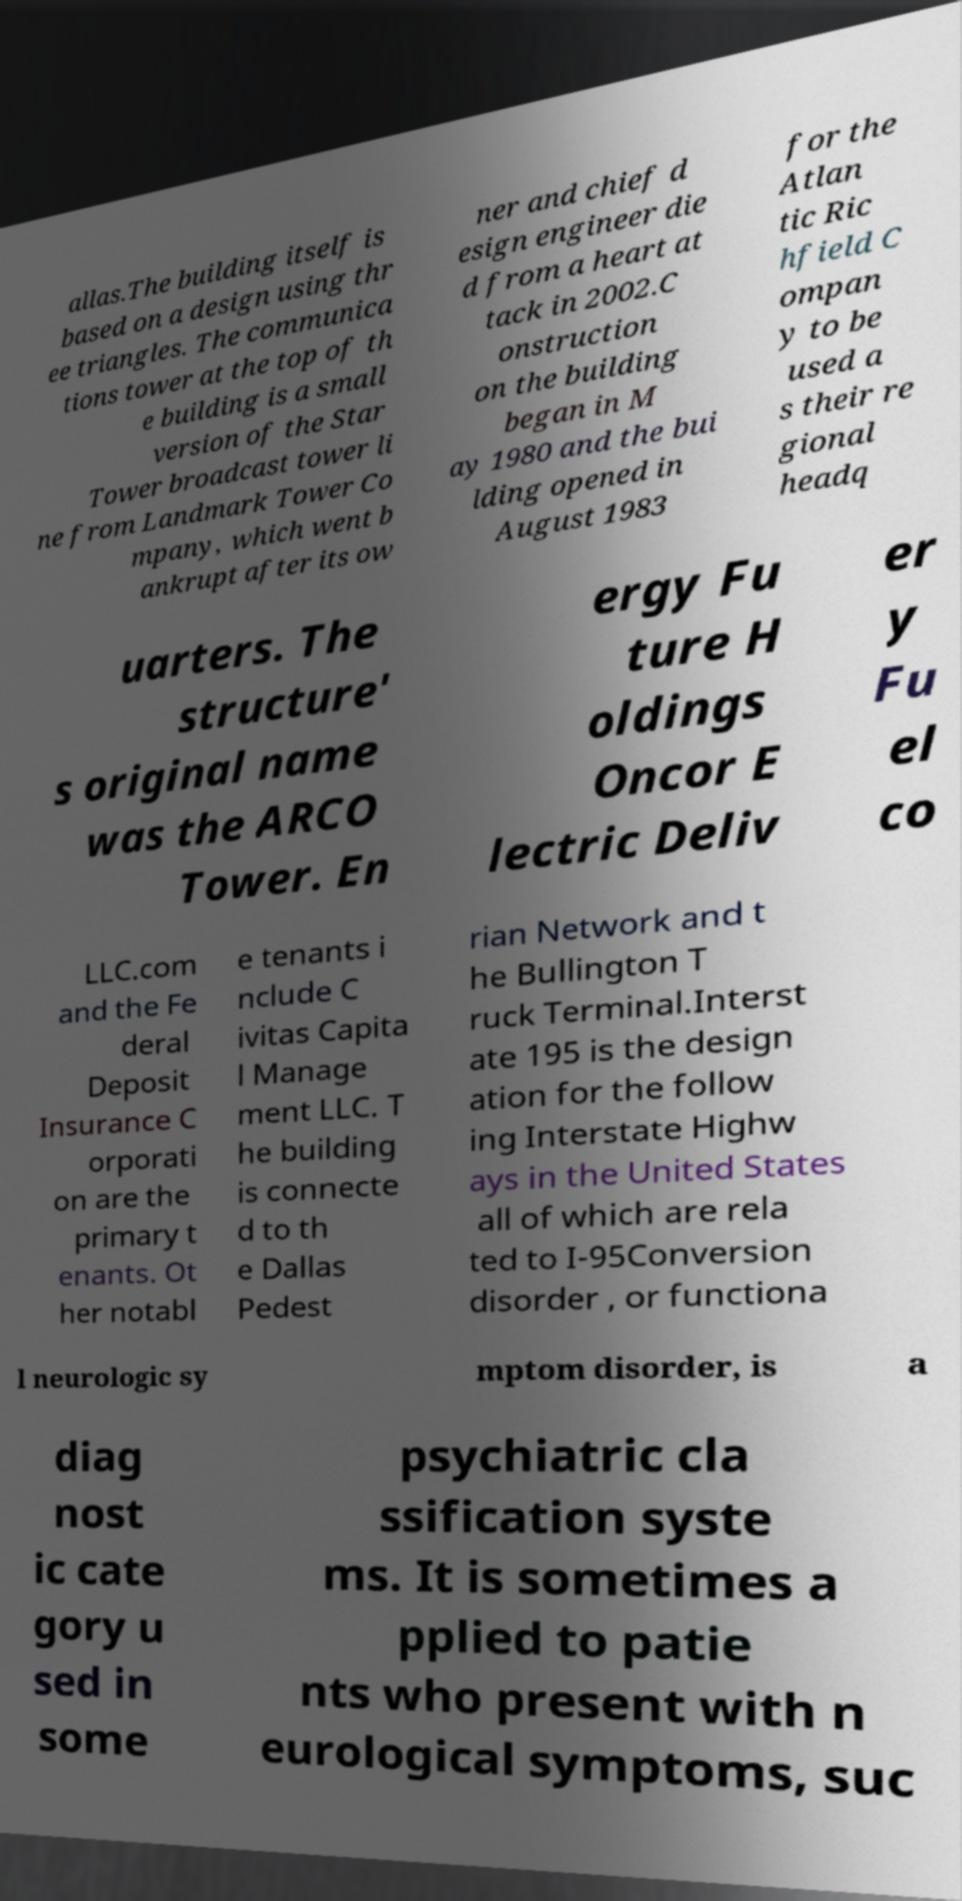For documentation purposes, I need the text within this image transcribed. Could you provide that? allas.The building itself is based on a design using thr ee triangles. The communica tions tower at the top of th e building is a small version of the Star Tower broadcast tower li ne from Landmark Tower Co mpany, which went b ankrupt after its ow ner and chief d esign engineer die d from a heart at tack in 2002.C onstruction on the building began in M ay 1980 and the bui lding opened in August 1983 for the Atlan tic Ric hfield C ompan y to be used a s their re gional headq uarters. The structure' s original name was the ARCO Tower. En ergy Fu ture H oldings Oncor E lectric Deliv er y Fu el co LLC.com and the Fe deral Deposit Insurance C orporati on are the primary t enants. Ot her notabl e tenants i nclude C ivitas Capita l Manage ment LLC. T he building is connecte d to th e Dallas Pedest rian Network and t he Bullington T ruck Terminal.Interst ate 195 is the design ation for the follow ing Interstate Highw ays in the United States all of which are rela ted to I-95Conversion disorder , or functiona l neurologic sy mptom disorder, is a diag nost ic cate gory u sed in some psychiatric cla ssification syste ms. It is sometimes a pplied to patie nts who present with n eurological symptoms, suc 